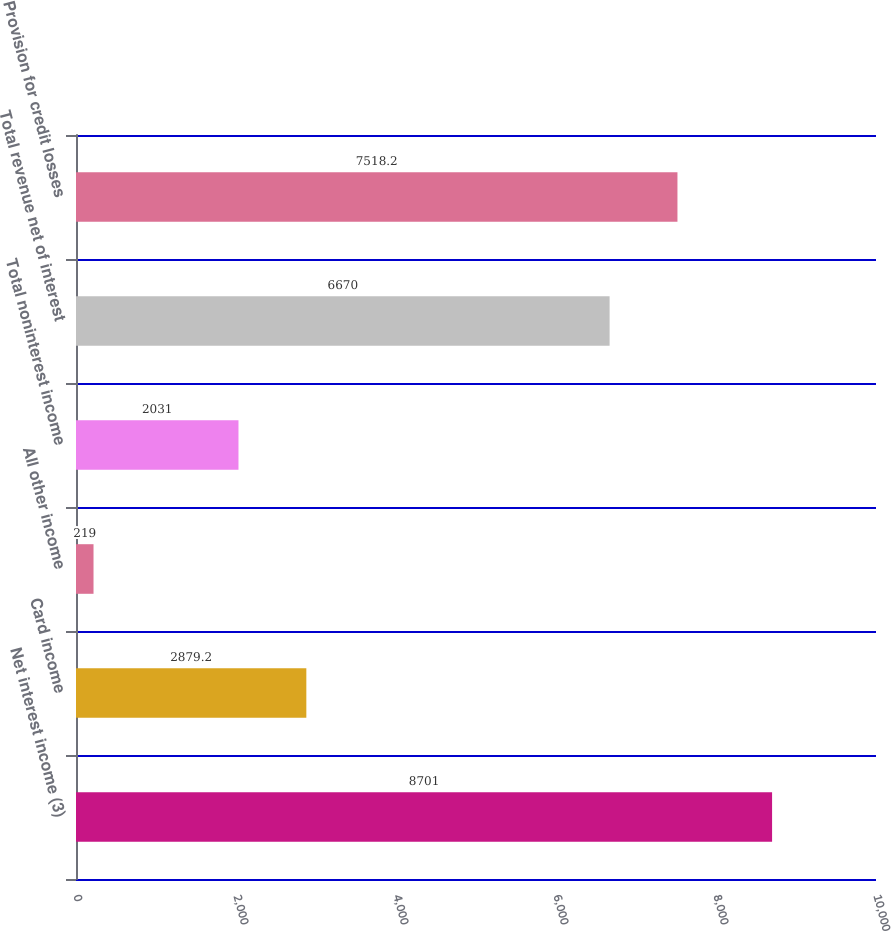Convert chart to OTSL. <chart><loc_0><loc_0><loc_500><loc_500><bar_chart><fcel>Net interest income (3)<fcel>Card income<fcel>All other income<fcel>Total noninterest income<fcel>Total revenue net of interest<fcel>Provision for credit losses<nl><fcel>8701<fcel>2879.2<fcel>219<fcel>2031<fcel>6670<fcel>7518.2<nl></chart> 